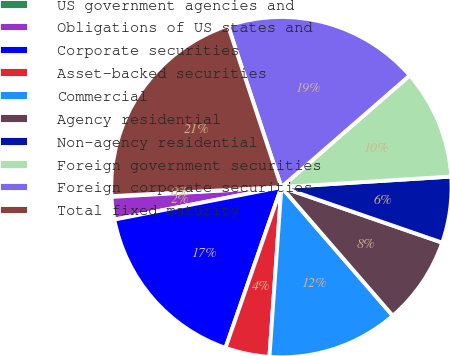Convert chart to OTSL. <chart><loc_0><loc_0><loc_500><loc_500><pie_chart><fcel>US government agencies and<fcel>Obligations of US states and<fcel>Corporate securities<fcel>Asset-backed securities<fcel>Commercial<fcel>Agency residential<fcel>Non-agency residential<fcel>Foreign government securities<fcel>Foreign corporate securities<fcel>Total fixed maturity<nl><fcel>0.07%<fcel>2.14%<fcel>16.62%<fcel>4.21%<fcel>12.48%<fcel>8.35%<fcel>6.28%<fcel>10.41%<fcel>18.69%<fcel>20.76%<nl></chart> 